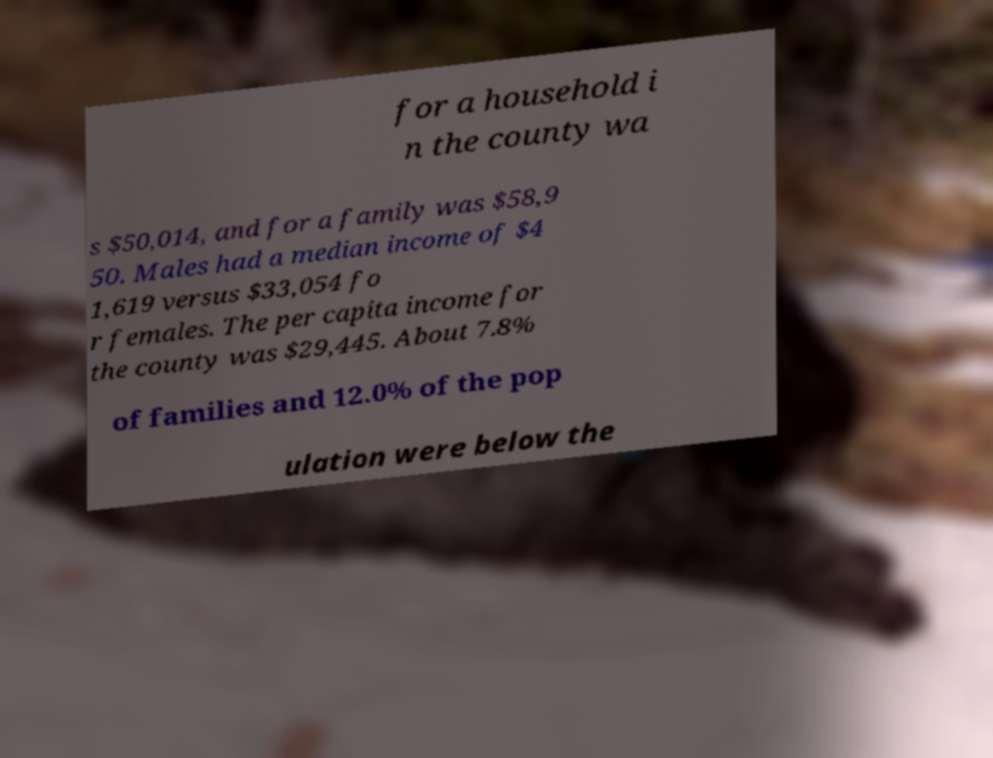Please identify and transcribe the text found in this image. for a household i n the county wa s $50,014, and for a family was $58,9 50. Males had a median income of $4 1,619 versus $33,054 fo r females. The per capita income for the county was $29,445. About 7.8% of families and 12.0% of the pop ulation were below the 